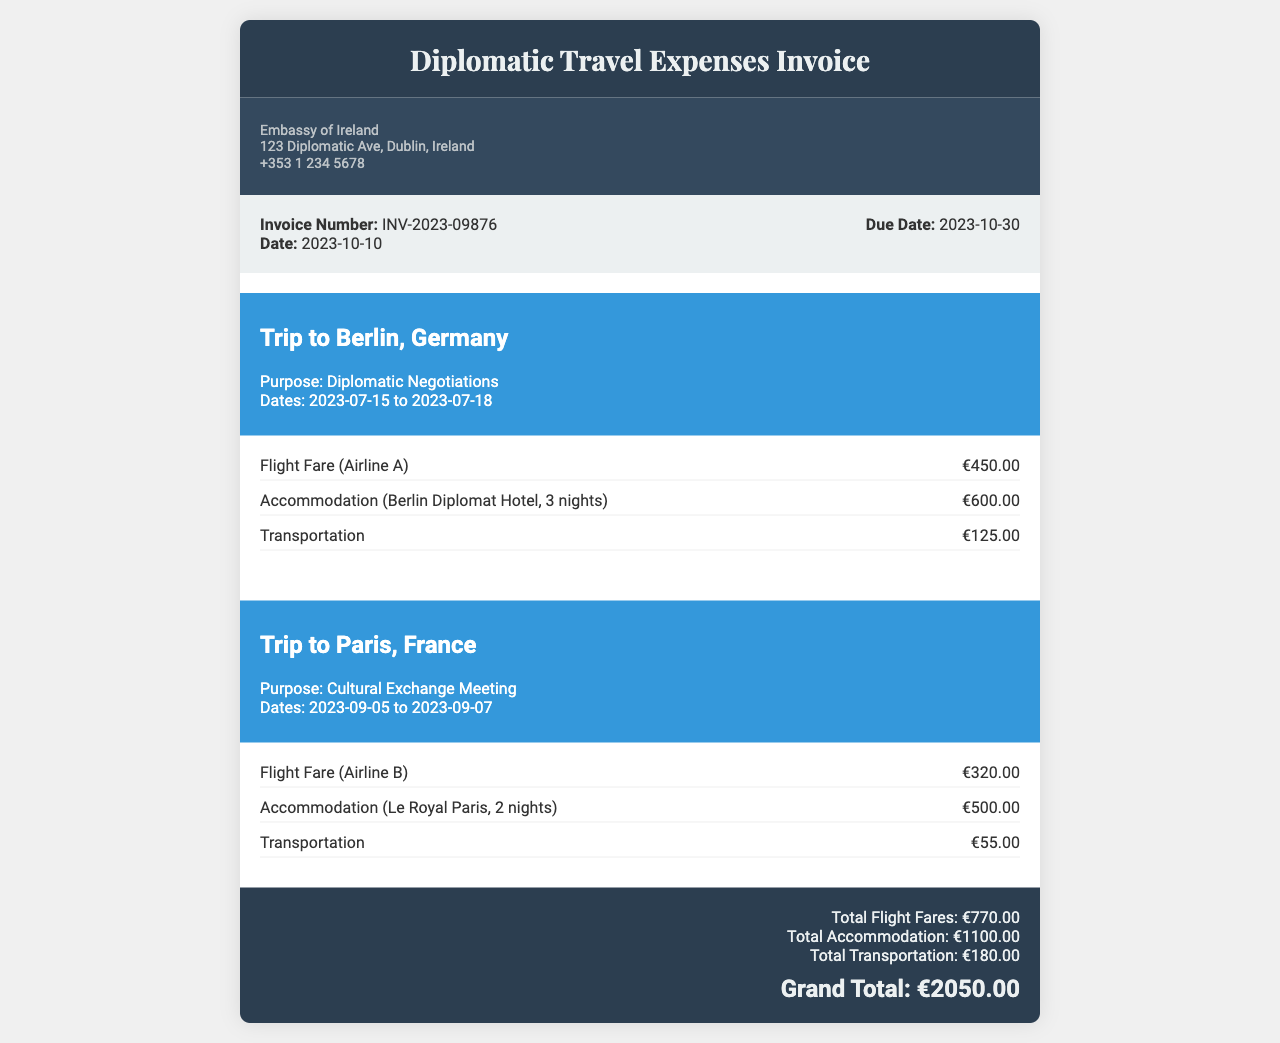what is the invoice number? The invoice number is listed under the invoice details section as INV-2023-09876.
Answer: INV-2023-09876 what is the total accommodation cost? The total accommodation cost is the sum of accommodation expenses for both trips, which is €600.00 + €500.00.
Answer: €1100.00 how many nights was the accommodation for the trip to Paris? The accommodation for the trip to Paris was for 2 nights, as stated in the expense details.
Answer: 2 nights what was the purpose of the trip to Berlin? The purpose of the trip to Berlin is mentioned as "Diplomatic Negotiations".
Answer: Diplomatic Negotiations how much was spent on transportation in total? The total spent on transportation is the sum of transportation expenses for both trips, which is €125.00 + €55.00.
Answer: €180.00 when was the trip to Paris? The dates of the trip to Paris are indicated as 2023-09-05 to 2023-09-07.
Answer: 2023-09-05 to 2023-09-07 what was the grand total of expenses? The grand total is clearly stated as €2050.00 in the summary section of the invoice.
Answer: €2050.00 which hotel was used for the accommodation in Berlin? The hotel used for the accommodation in Berlin is specified as Berlin Diplomat Hotel.
Answer: Berlin Diplomat Hotel 